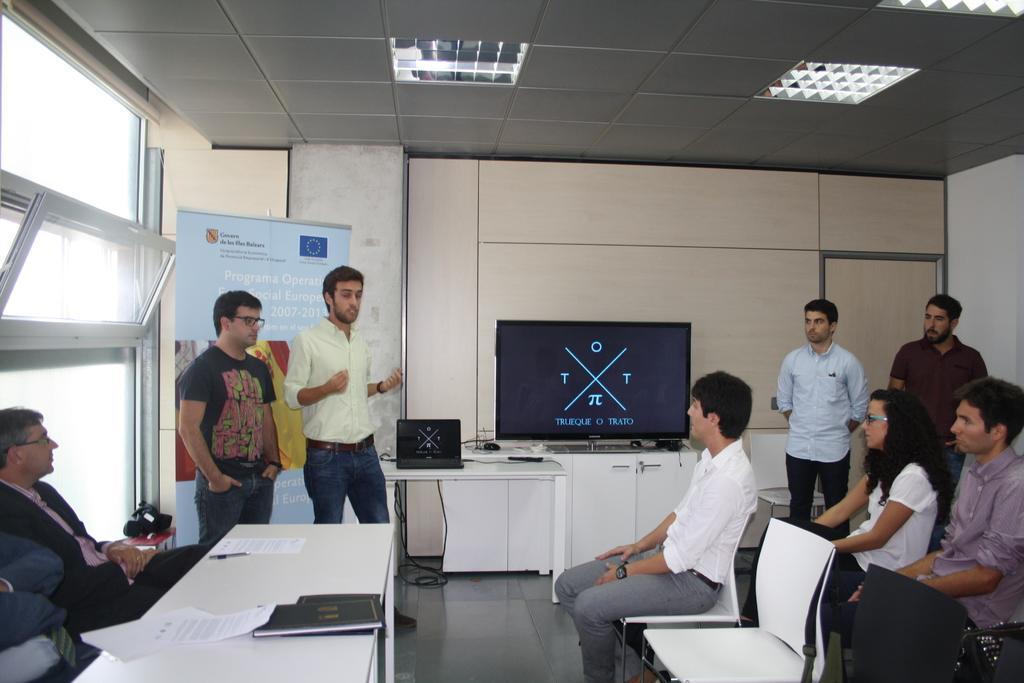How would you summarize this image in a sentence or two? In this image there is a hall in which there are few people sitting in the chairs on the right side. On the left side there is a table on which there are books and papers. Beside the table there are few officers sitting in the chairs. At the top there is ceiling with the lights. In the middle there are two men who are standing on the floor. In the background there is a television on the table and there is a laptop beside it. On the left side there is a banner. Beside the banner there is a window. 